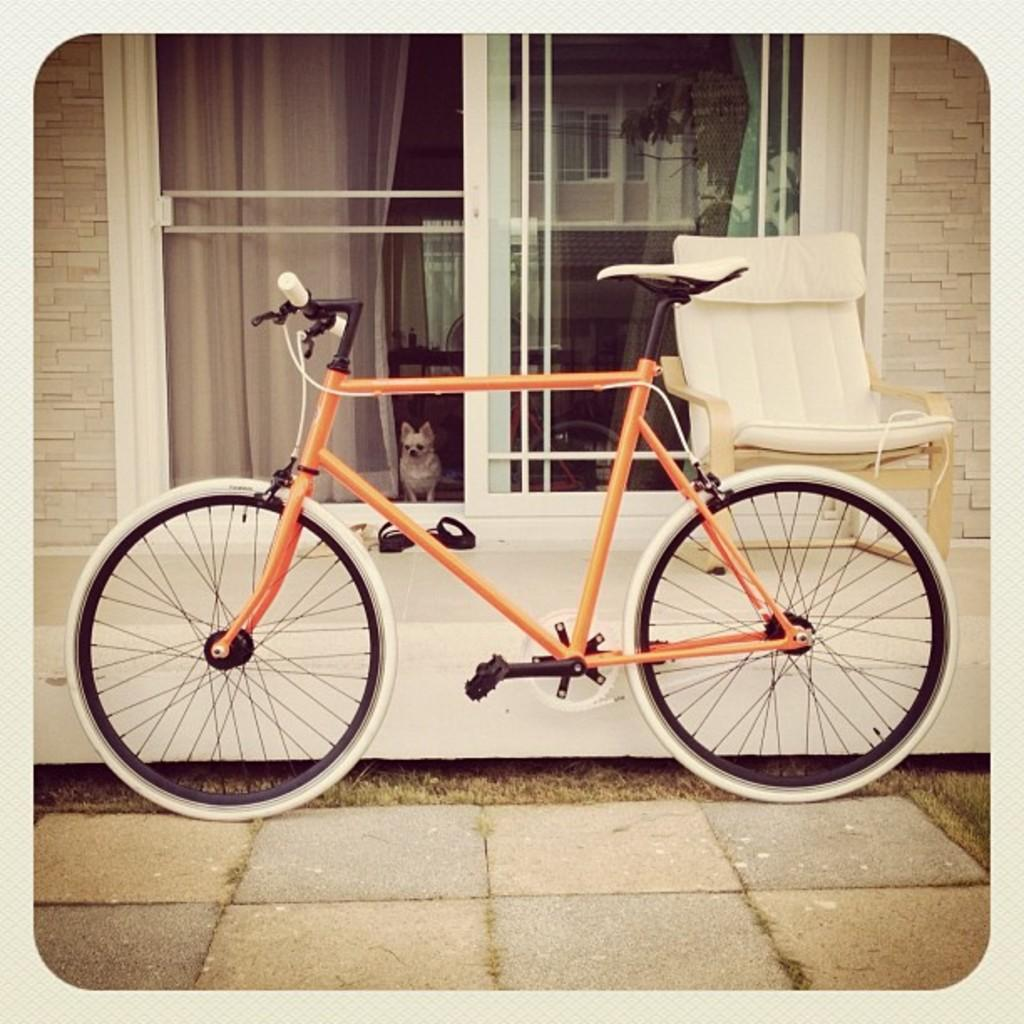What object is placed on the ground in the image? There is a bicycle placed on the ground. What can be seen in the background of the image? There is a chair, a door, a dog, a group of shoes, and curtains in the background. Can you describe the door in the background? The door is in the background, but its specific characteristics are not mentioned in the provided facts. What might be used for cleaning or wiping in the image? The group of shoes in the background suggests that people might be using them for walking or cleaning. How many cakes are being hammered by the fly in the image? There are no cakes, flies, or hammers present in the image. 